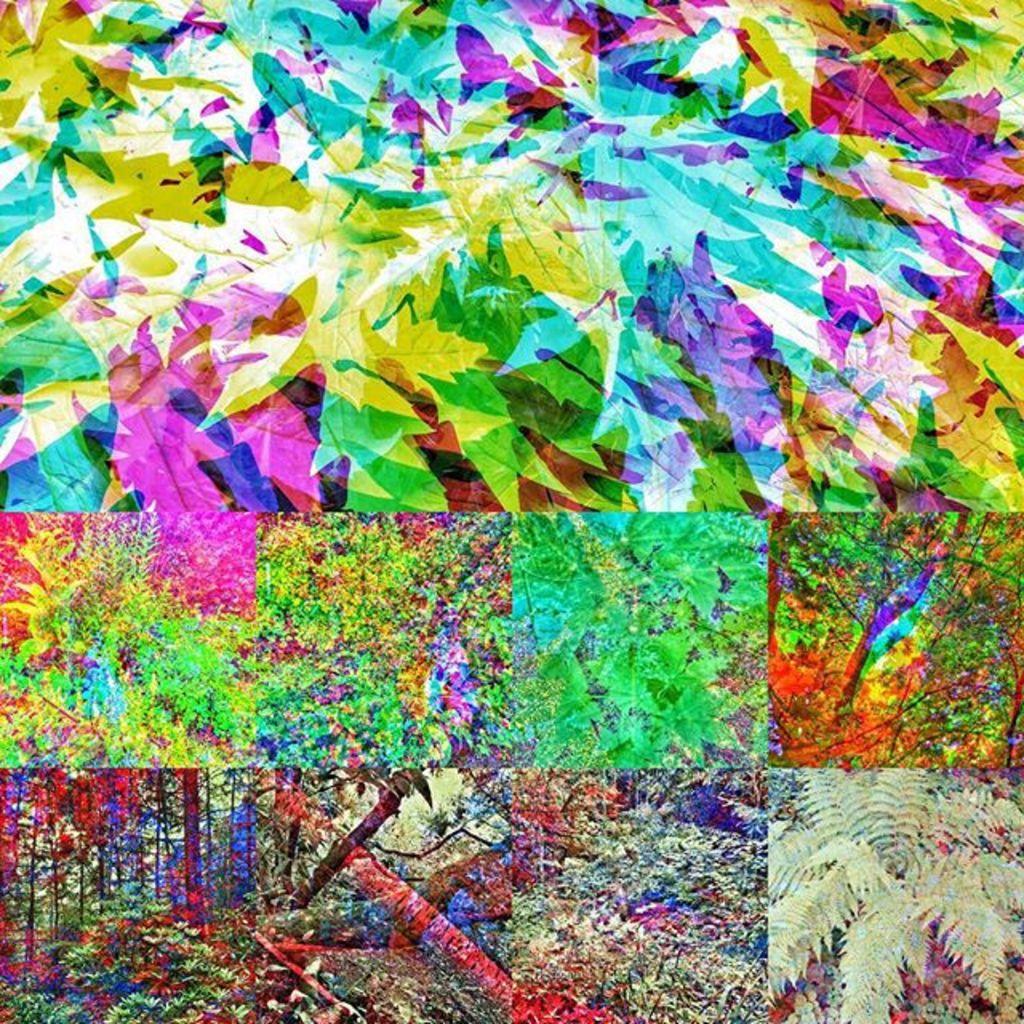In one or two sentences, can you explain what this image depicts? This is a collage image. In this image I can see the colorful leaves and trees. 